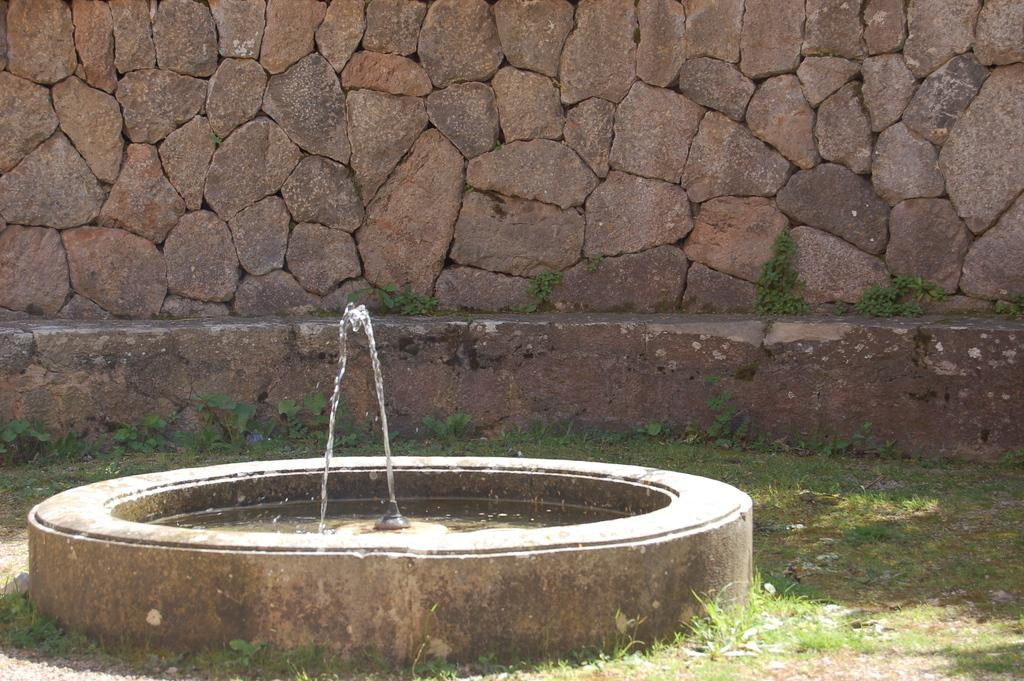What is one of the main features in the image? There is a wall in the image. What type of natural elements can be seen in the image? There are plants in the image. What is located in the foreground of the image? There appears to be a fountain in the foreground of the image. What is the primary liquid element in the image? There is water in the image. Where are the plants located in the image? There are plants at the bottom of the image. What is visible at the bottom of the image? The ground is visible at the bottom of the image. What type of invention is being demonstrated in the image? There is no invention being demonstrated in the image; it primarily features a wall, plants, a fountain, water, and the ground. Can you see a badge on any of the plants in the image? There are no badges present on the plants in the image. 